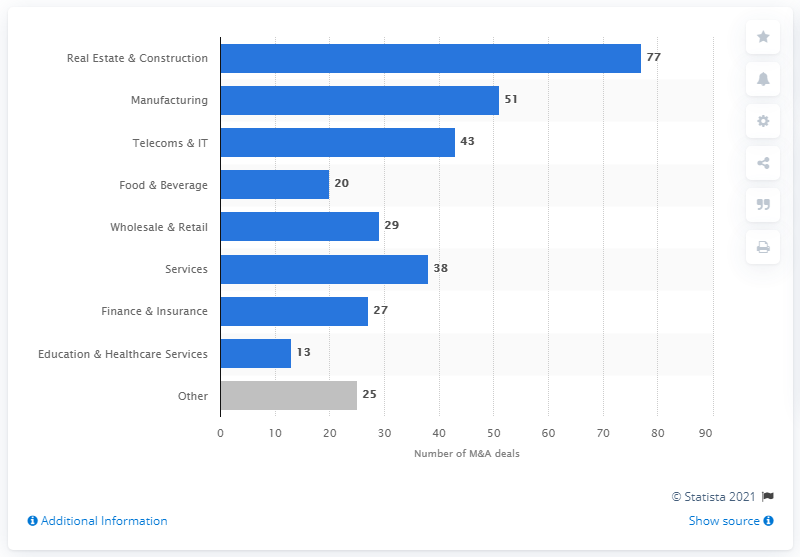Can you describe the trend in the number of transactions across different sectors? Certainly! As seen in the bar chart, the Real Estate & Construction sector leads with 77 transactions in Poland for 2018. Manufacturing follows with 51 transactions, and Telecoms & IT is close behind with 43. Other sectors like Food & Beverage, Wholesale & Retail, and Services also show significant activity with 20, 29, and 38 transactions respectively. Finance & Insurance, and Education & Healthcare Services appear less active, with 27 and 13 transactions. 'Other' sectors contribute 25 deals, indicating a diverse but uneven distribution of transactions across industries. 